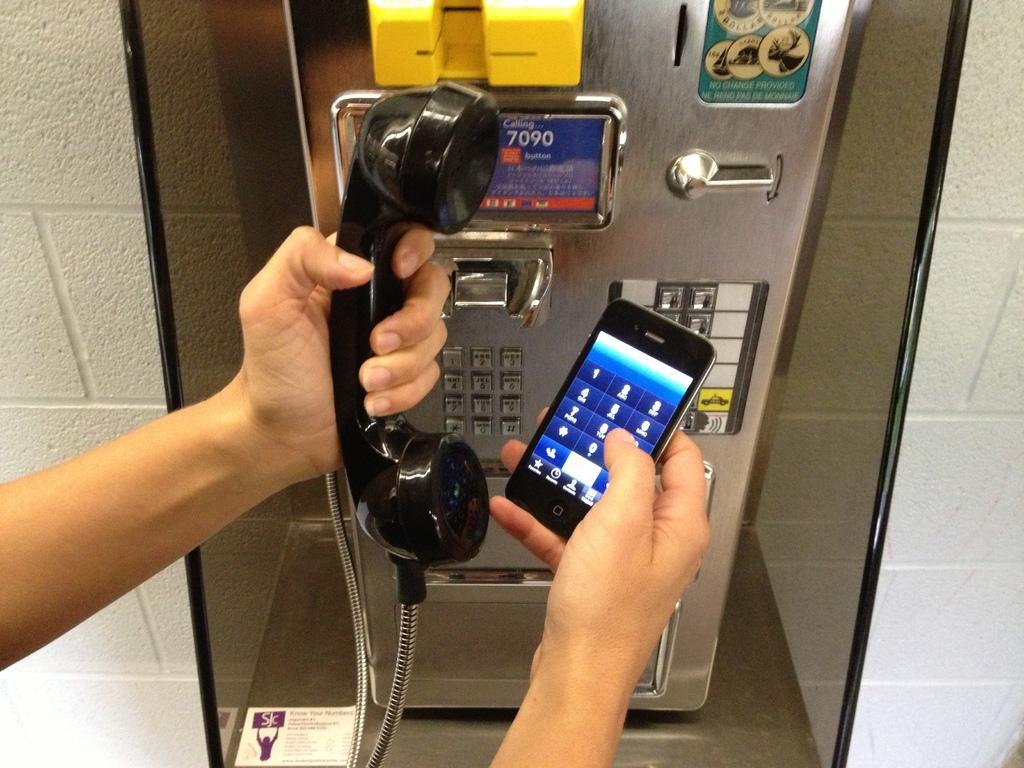Could you give a brief overview of what you see in this image? In this picture I can observe a telephone and a mobile in the hands of the human. In the background I can observe a wall. 